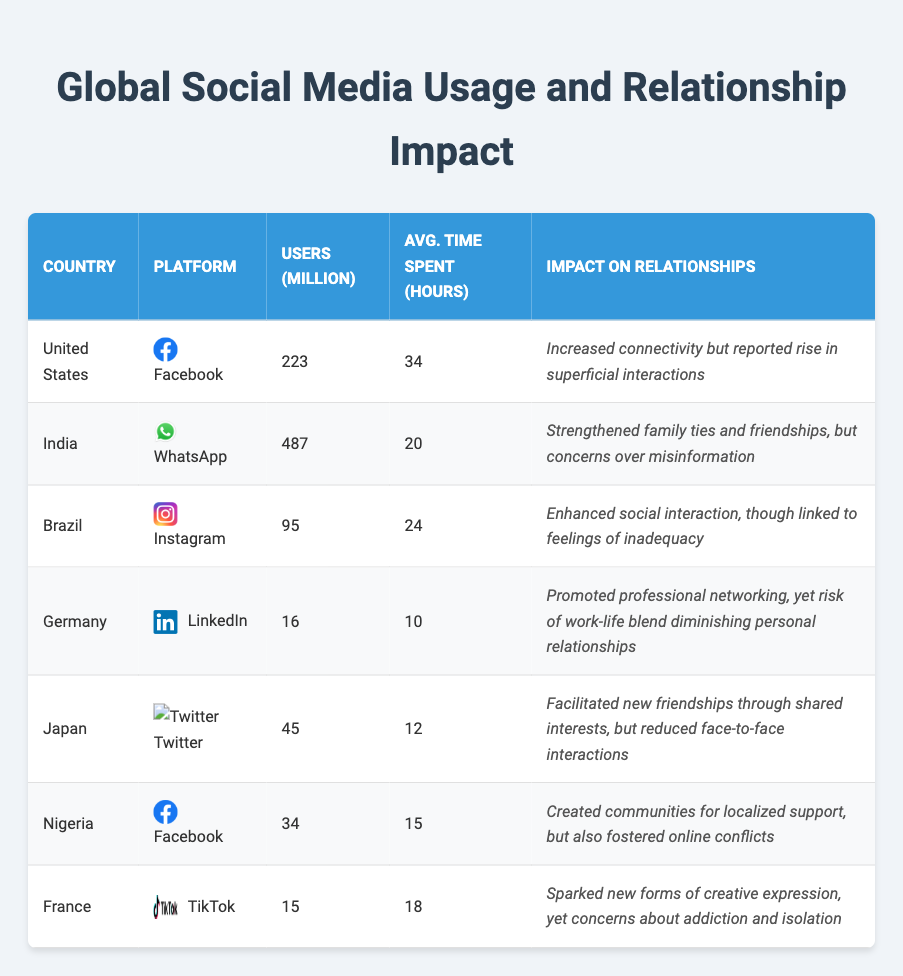What is the total number of social media users in India? The table shows that India has 487 million users on WhatsApp. Since it is the only entry for India in the table, the total is simply the number of users listed.
Answer: 487 million Which country uses Facebook and has the highest average time spent by users? In the table, both the United States and Nigeria use Facebook. The average time spent in the United States is 34 hours, and in Nigeria, it is 15 hours. Since 34 hours is greater than 15 hours, the United States has the highest average time spent.
Answer: United States What is the difference in users (in millions) between Brazil's Instagram and France's TikTok? Brazil has 95 million users on Instagram and France has 15 million users on TikTok. To find the difference, subtract 15 from 95. Therefore, the difference is 95 - 15 = 80 million users.
Answer: 80 million Is there a higher average time spent on social media in Japan compared to Germany? The average time spent in Japan is 12 hours while in Germany it is 10 hours. Since 12 is greater than 10, the statement is true.
Answer: Yes What is the percentage of users in Brazil compared to the total users of all platforms listed? To find the total users, add all users: 223 (US) + 487 (India) + 95 (Brazil) + 16 (Germany) + 45 (Japan) + 34 (Nigeria) + 15 (France) = 900 million. Then, calculate Brazil's percentage: (95 / 900) * 100 ≈ 10.56%.
Answer: 10.56% Which platform has the least impact on relationships, according to the table? The table describes the impact on relationships for each platform. LinkedIn has the impact "Promoted professional networking, yet risk of work-life blend diminishing personal relationships," which indicates significant concerns about personal relationships, making it appear less positive compared to others.
Answer: LinkedIn How many countries use Facebook as their primary social media platform? The table shows that both the United States and Nigeria use Facebook. Therefore, to find the number of countries, we simply count the entries: there are 2 countries using Facebook.
Answer: 2 What is the average time spent on social media platforms listed in the table? To calculate the average, sum all average times: 34 (US) + 20 (India) + 24 (Brazil) + 10 (Germany) + 12 (Japan) + 15 (Nigeria) + 18 (France) = 133 hours. Then divide by the 7 platforms: 133 / 7 ≈ 19 hours.
Answer: 19 hours 